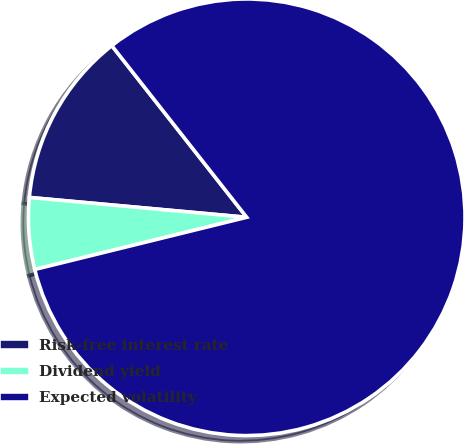Convert chart. <chart><loc_0><loc_0><loc_500><loc_500><pie_chart><fcel>Risk-free interest rate<fcel>Dividend yield<fcel>Expected volatility<nl><fcel>12.95%<fcel>5.29%<fcel>81.76%<nl></chart> 